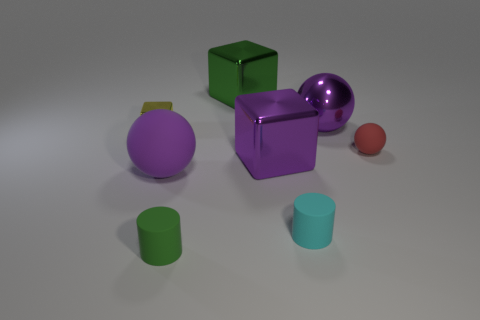Add 1 red matte objects. How many objects exist? 9 Subtract all cubes. How many objects are left? 5 Add 8 metallic spheres. How many metallic spheres are left? 9 Add 7 yellow matte balls. How many yellow matte balls exist? 7 Subtract 1 red spheres. How many objects are left? 7 Subtract all yellow cubes. Subtract all yellow metal objects. How many objects are left? 6 